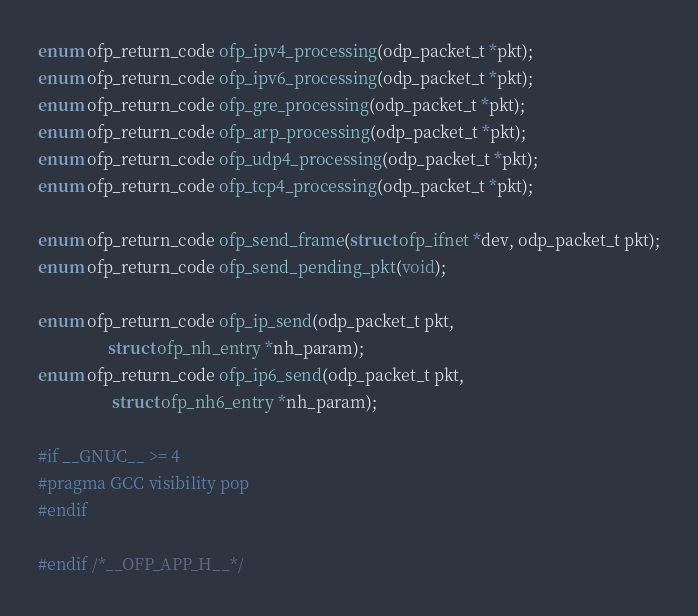<code> <loc_0><loc_0><loc_500><loc_500><_C_>enum ofp_return_code ofp_ipv4_processing(odp_packet_t *pkt);
enum ofp_return_code ofp_ipv6_processing(odp_packet_t *pkt);
enum ofp_return_code ofp_gre_processing(odp_packet_t *pkt);
enum ofp_return_code ofp_arp_processing(odp_packet_t *pkt);
enum ofp_return_code ofp_udp4_processing(odp_packet_t *pkt);
enum ofp_return_code ofp_tcp4_processing(odp_packet_t *pkt);

enum ofp_return_code ofp_send_frame(struct ofp_ifnet *dev, odp_packet_t pkt);
enum ofp_return_code ofp_send_pending_pkt(void);

enum ofp_return_code ofp_ip_send(odp_packet_t pkt,
				 struct ofp_nh_entry *nh_param);
enum ofp_return_code ofp_ip6_send(odp_packet_t pkt,
				  struct ofp_nh6_entry *nh_param);

#if __GNUC__ >= 4
#pragma GCC visibility pop
#endif

#endif /*__OFP_APP_H__*/
</code> 